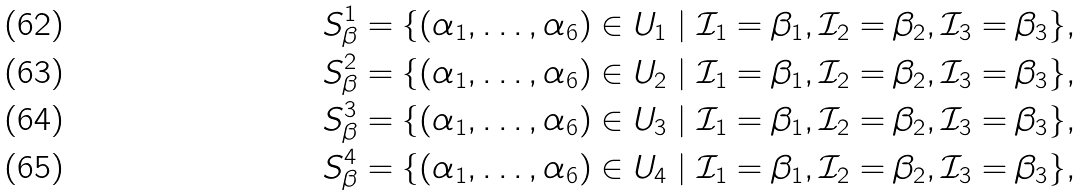Convert formula to latex. <formula><loc_0><loc_0><loc_500><loc_500>S ^ { 1 } _ { \beta } = \{ ( \alpha _ { 1 } , \dots , \alpha _ { 6 } ) \in U _ { 1 } \ | \ \mathcal { I } _ { 1 } = \beta _ { 1 } , \mathcal { I } _ { 2 } = \beta _ { 2 } , \mathcal { I } _ { 3 } = \beta _ { 3 } \} , \\ S ^ { 2 } _ { \beta } = \{ ( \alpha _ { 1 } , \dots , \alpha _ { 6 } ) \in U _ { 2 } \ | \ \mathcal { I } _ { 1 } = \beta _ { 1 } , \mathcal { I } _ { 2 } = \beta _ { 2 } , \mathcal { I } _ { 3 } = \beta _ { 3 } \} , \\ S ^ { 3 } _ { \beta } = \{ ( \alpha _ { 1 } , \dots , \alpha _ { 6 } ) \in U _ { 3 } \ | \ \mathcal { I } _ { 1 } = \beta _ { 1 } , \mathcal { I } _ { 2 } = \beta _ { 2 } , \mathcal { I } _ { 3 } = \beta _ { 3 } \} , \\ S ^ { 4 } _ { \beta } = \{ ( \alpha _ { 1 } , \dots , \alpha _ { 6 } ) \in U _ { 4 } \ | \ \mathcal { I } _ { 1 } = \beta _ { 1 } , \mathcal { I } _ { 2 } = \beta _ { 2 } , \mathcal { I } _ { 3 } = \beta _ { 3 } \} ,</formula> 